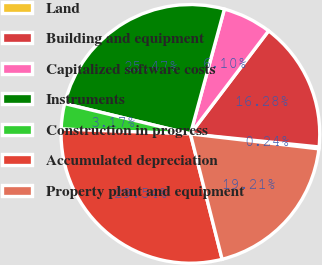Convert chart. <chart><loc_0><loc_0><loc_500><loc_500><pie_chart><fcel>Land<fcel>Building and equipment<fcel>Capitalized software costs<fcel>Instruments<fcel>Construction in progress<fcel>Accumulated depreciation<fcel>Property plant and equipment<nl><fcel>0.24%<fcel>16.28%<fcel>6.1%<fcel>25.47%<fcel>3.17%<fcel>29.54%<fcel>19.21%<nl></chart> 